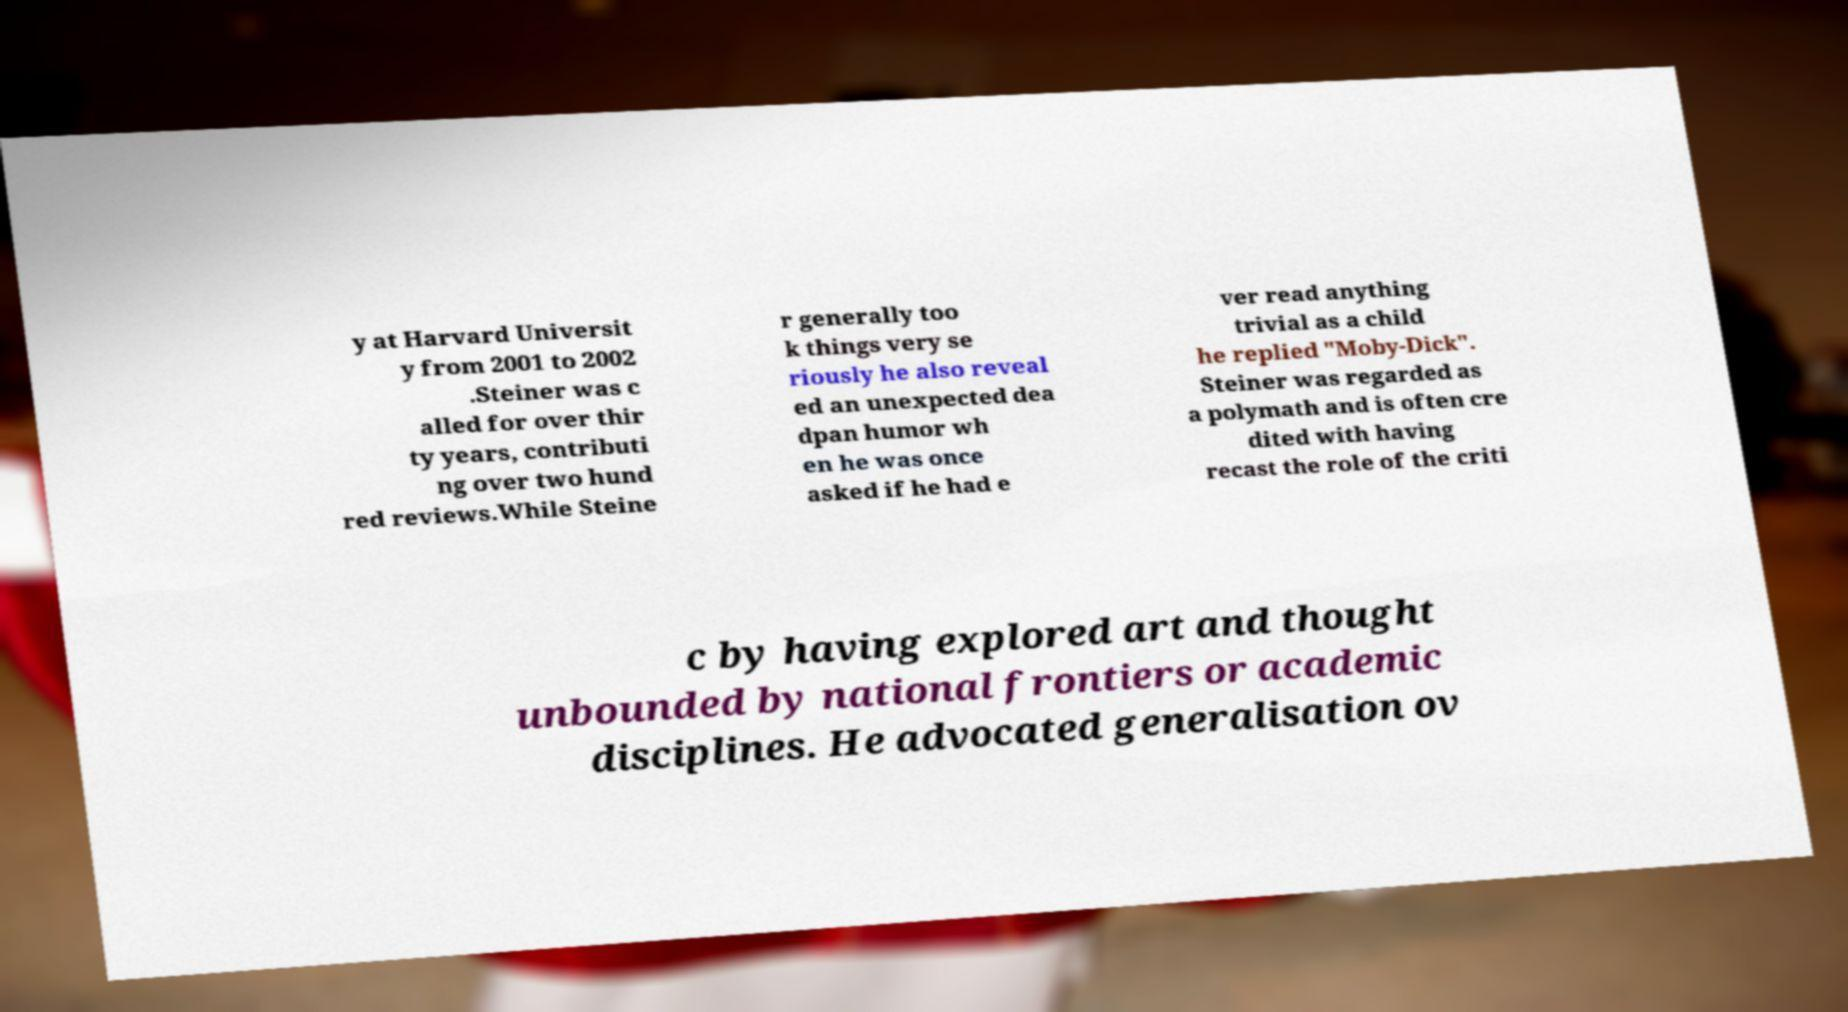I need the written content from this picture converted into text. Can you do that? y at Harvard Universit y from 2001 to 2002 .Steiner was c alled for over thir ty years, contributi ng over two hund red reviews.While Steine r generally too k things very se riously he also reveal ed an unexpected dea dpan humor wh en he was once asked if he had e ver read anything trivial as a child he replied "Moby-Dick". Steiner was regarded as a polymath and is often cre dited with having recast the role of the criti c by having explored art and thought unbounded by national frontiers or academic disciplines. He advocated generalisation ov 